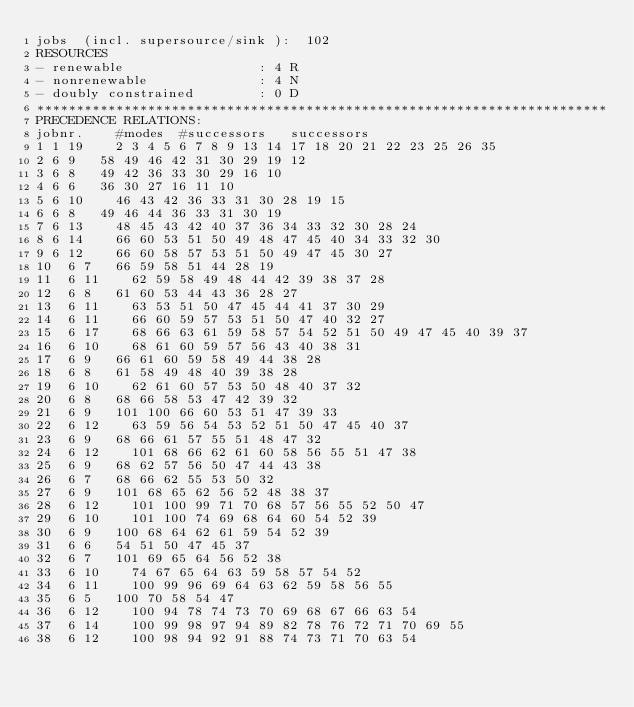<code> <loc_0><loc_0><loc_500><loc_500><_ObjectiveC_>jobs  (incl. supersource/sink ):	102
RESOURCES
- renewable                 : 4 R
- nonrenewable              : 4 N
- doubly constrained        : 0 D
************************************************************************
PRECEDENCE RELATIONS:
jobnr.    #modes  #successors   successors
1	1	19		2 3 4 5 6 7 8 9 13 14 17 18 20 21 22 23 25 26 35 
2	6	9		58 49 46 42 31 30 29 19 12 
3	6	8		49 42 36 33 30 29 16 10 
4	6	6		36 30 27 16 11 10 
5	6	10		46 43 42 36 33 31 30 28 19 15 
6	6	8		49 46 44 36 33 31 30 19 
7	6	13		48 45 43 42 40 37 36 34 33 32 30 28 24 
8	6	14		66 60 53 51 50 49 48 47 45 40 34 33 32 30 
9	6	12		66 60 58 57 53 51 50 49 47 45 30 27 
10	6	7		66 59 58 51 44 28 19 
11	6	11		62 59 58 49 48 44 42 39 38 37 28 
12	6	8		61 60 53 44 43 36 28 27 
13	6	11		63 53 51 50 47 45 44 41 37 30 29 
14	6	11		66 60 59 57 53 51 50 47 40 32 27 
15	6	17		68 66 63 61 59 58 57 54 52 51 50 49 47 45 40 39 37 
16	6	10		68 61 60 59 57 56 43 40 38 31 
17	6	9		66 61 60 59 58 49 44 38 28 
18	6	8		61 58 49 48 40 39 38 28 
19	6	10		62 61 60 57 53 50 48 40 37 32 
20	6	8		68 66 58 53 47 42 39 32 
21	6	9		101 100 66 60 53 51 47 39 33 
22	6	12		63 59 56 54 53 52 51 50 47 45 40 37 
23	6	9		68 66 61 57 55 51 48 47 32 
24	6	12		101 68 66 62 61 60 58 56 55 51 47 38 
25	6	9		68 62 57 56 50 47 44 43 38 
26	6	7		68 66 62 55 53 50 32 
27	6	9		101 68 65 62 56 52 48 38 37 
28	6	12		101 100 99 71 70 68 57 56 55 52 50 47 
29	6	10		101 100 74 69 68 64 60 54 52 39 
30	6	9		100 68 64 62 61 59 54 52 39 
31	6	6		54 51 50 47 45 37 
32	6	7		101 69 65 64 56 52 38 
33	6	10		74 67 65 64 63 59 58 57 54 52 
34	6	11		100 99 96 69 64 63 62 59 58 56 55 
35	6	5		100 70 58 54 47 
36	6	12		100 94 78 74 73 70 69 68 67 66 63 54 
37	6	14		100 99 98 97 94 89 82 78 76 72 71 70 69 55 
38	6	12		100 98 94 92 91 88 74 73 71 70 63 54 </code> 